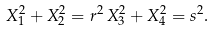<formula> <loc_0><loc_0><loc_500><loc_500>X _ { 1 } ^ { 2 } + X _ { 2 } ^ { 2 } = r ^ { 2 } \, X _ { 3 } ^ { 2 } + X _ { 4 } ^ { 2 } = s ^ { 2 } .</formula> 